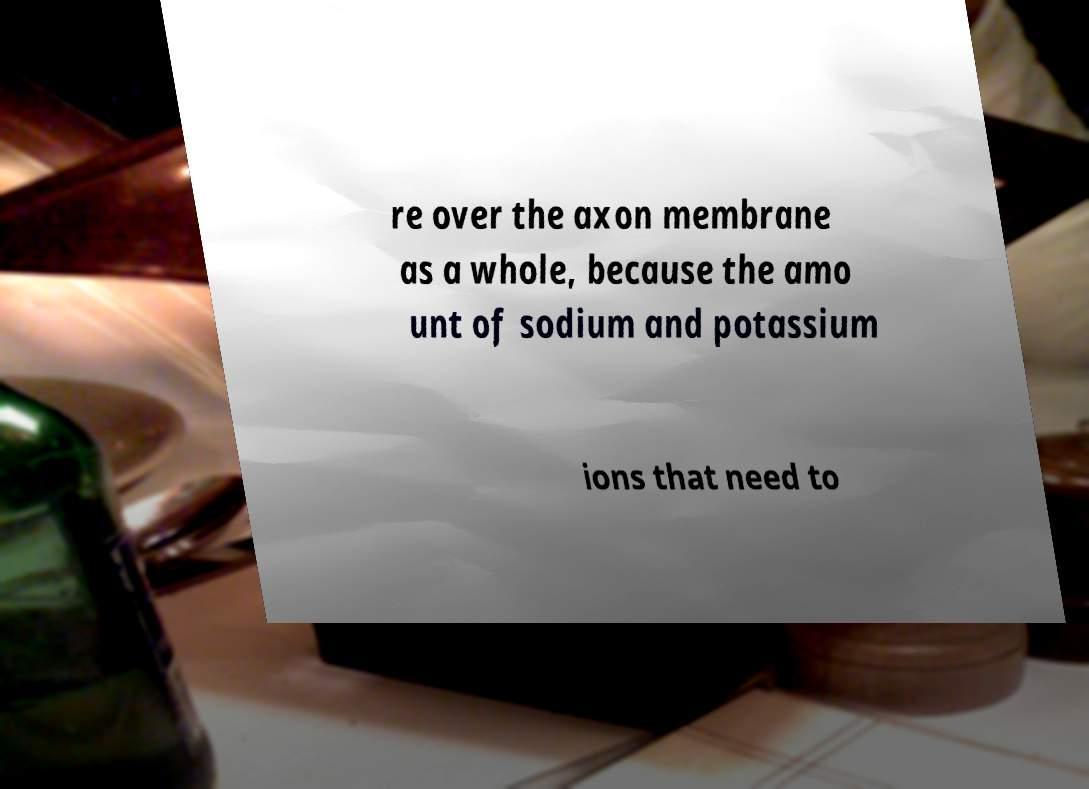There's text embedded in this image that I need extracted. Can you transcribe it verbatim? re over the axon membrane as a whole, because the amo unt of sodium and potassium ions that need to 